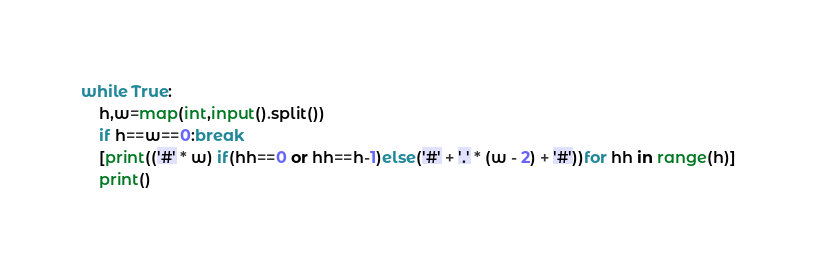Convert code to text. <code><loc_0><loc_0><loc_500><loc_500><_Python_>while True:
	h,w=map(int,input().split())
	if h==w==0:break
	[print(('#' * w) if(hh==0 or hh==h-1)else('#' + '.' * (w - 2) + '#'))for hh in range(h)]
	print()</code> 